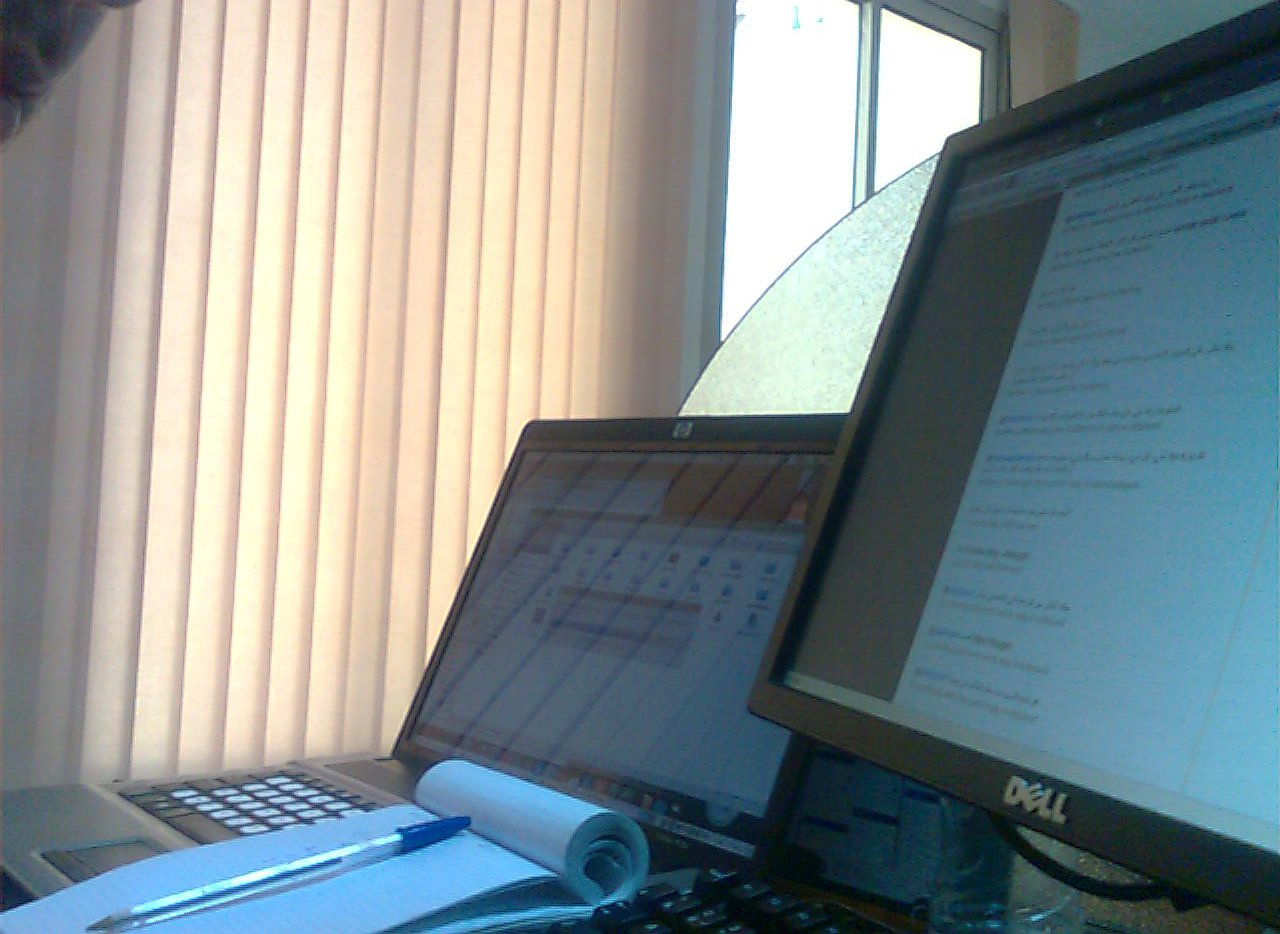Which kind of device is to the right of the blinds? To the right of the blinds, there's a computer monitor, which is an essential part of the desk setup. 